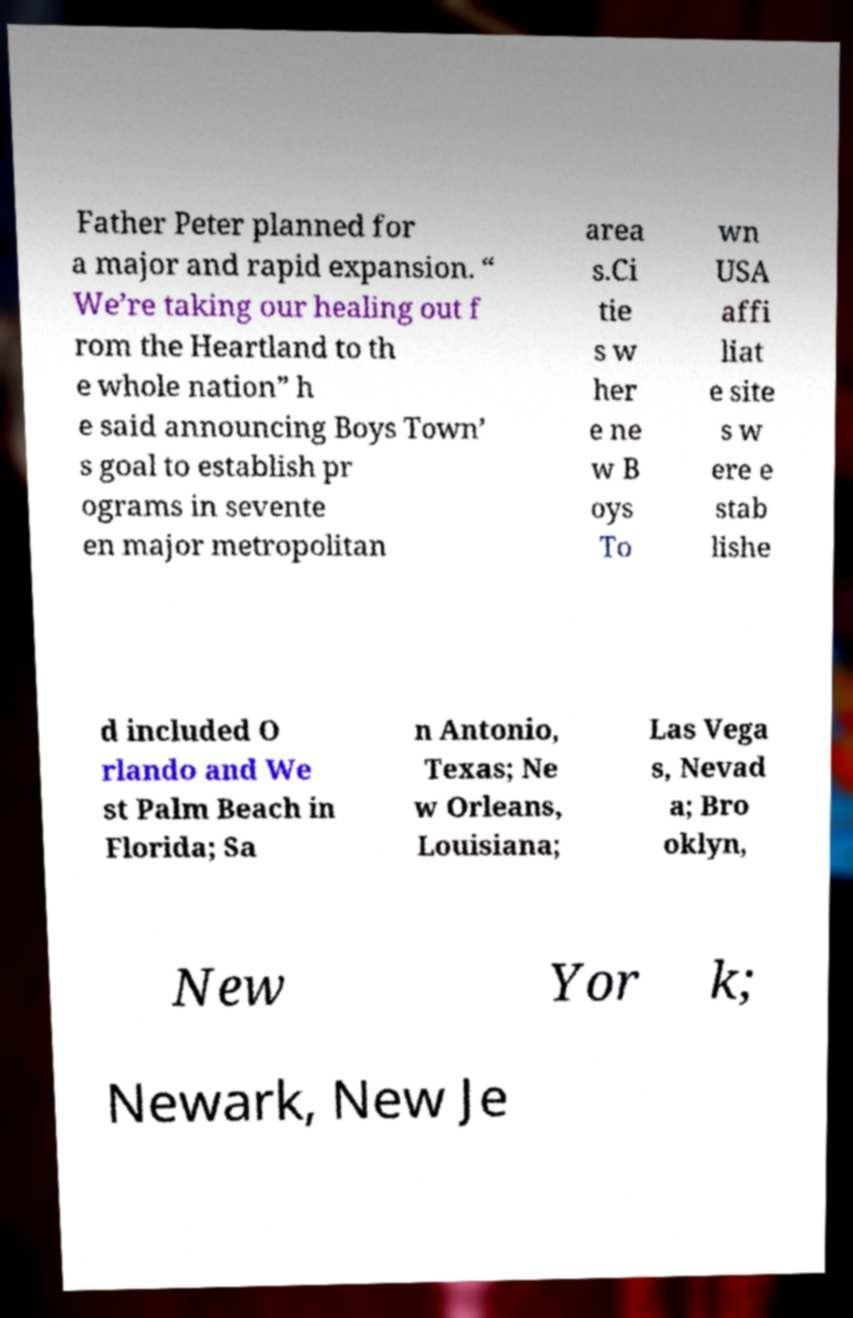Can you accurately transcribe the text from the provided image for me? Father Peter planned for a major and rapid expansion. “ We’re taking our healing out f rom the Heartland to th e whole nation” h e said announcing Boys Town’ s goal to establish pr ograms in sevente en major metropolitan area s.Ci tie s w her e ne w B oys To wn USA affi liat e site s w ere e stab lishe d included O rlando and We st Palm Beach in Florida; Sa n Antonio, Texas; Ne w Orleans, Louisiana; Las Vega s, Nevad a; Bro oklyn, New Yor k; Newark, New Je 